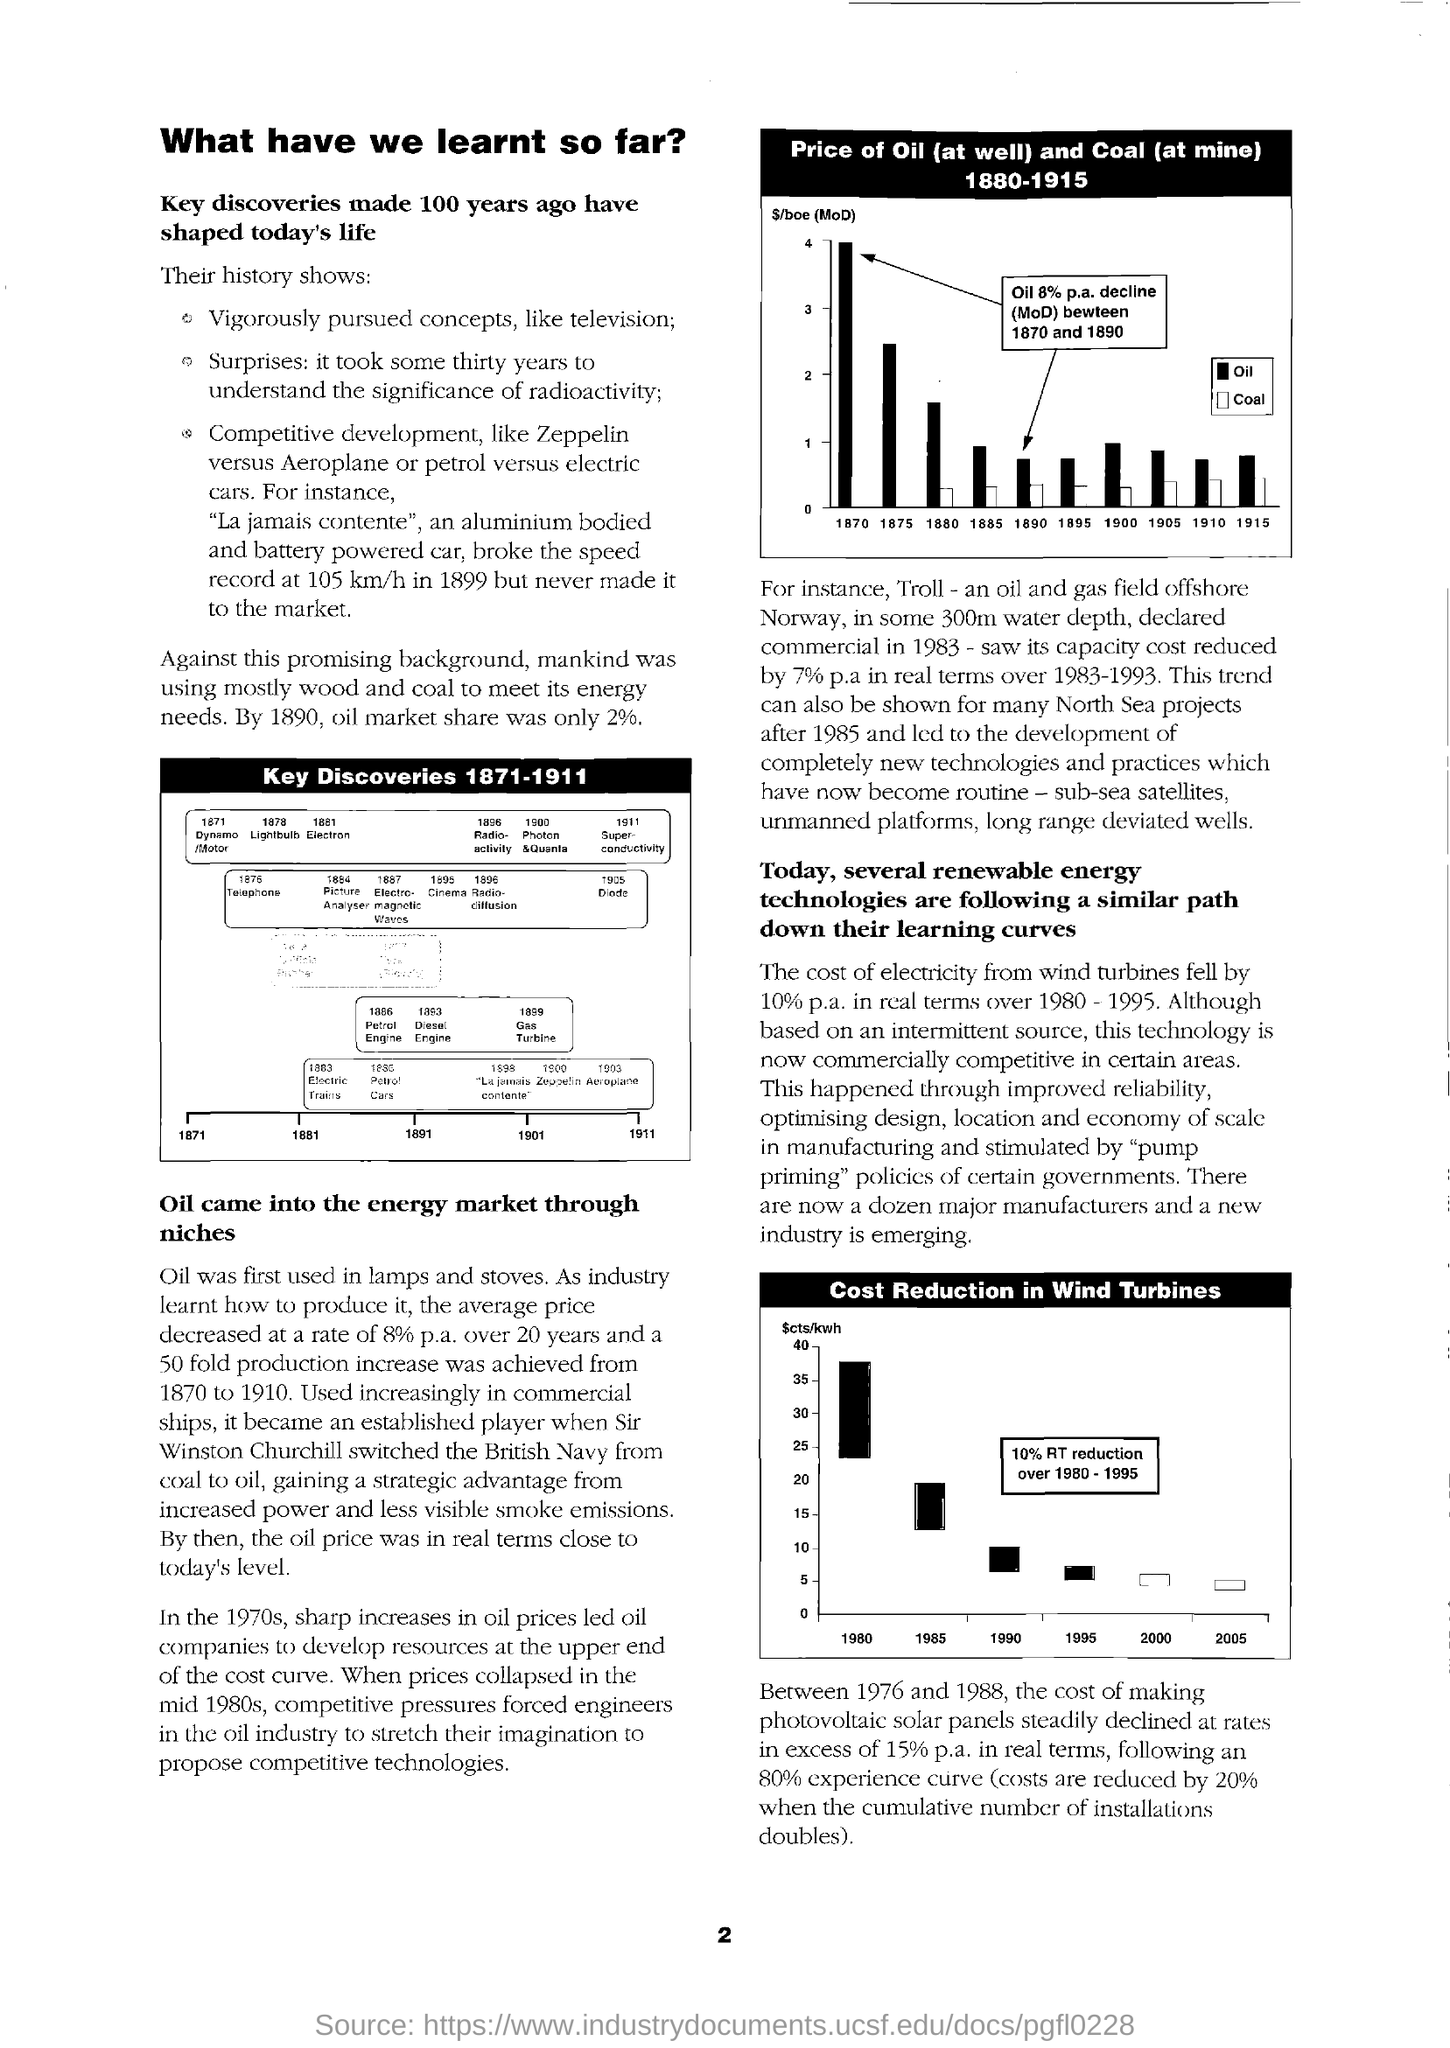Specify some key components in this picture. The key discoveries made 100 years ago have had a profound impact on our lives today and continue to shape our world. The cost of electricity generated by wind turbines has decreased by 10% per year on average. In 1890, oil market shares were a mere 2%. 